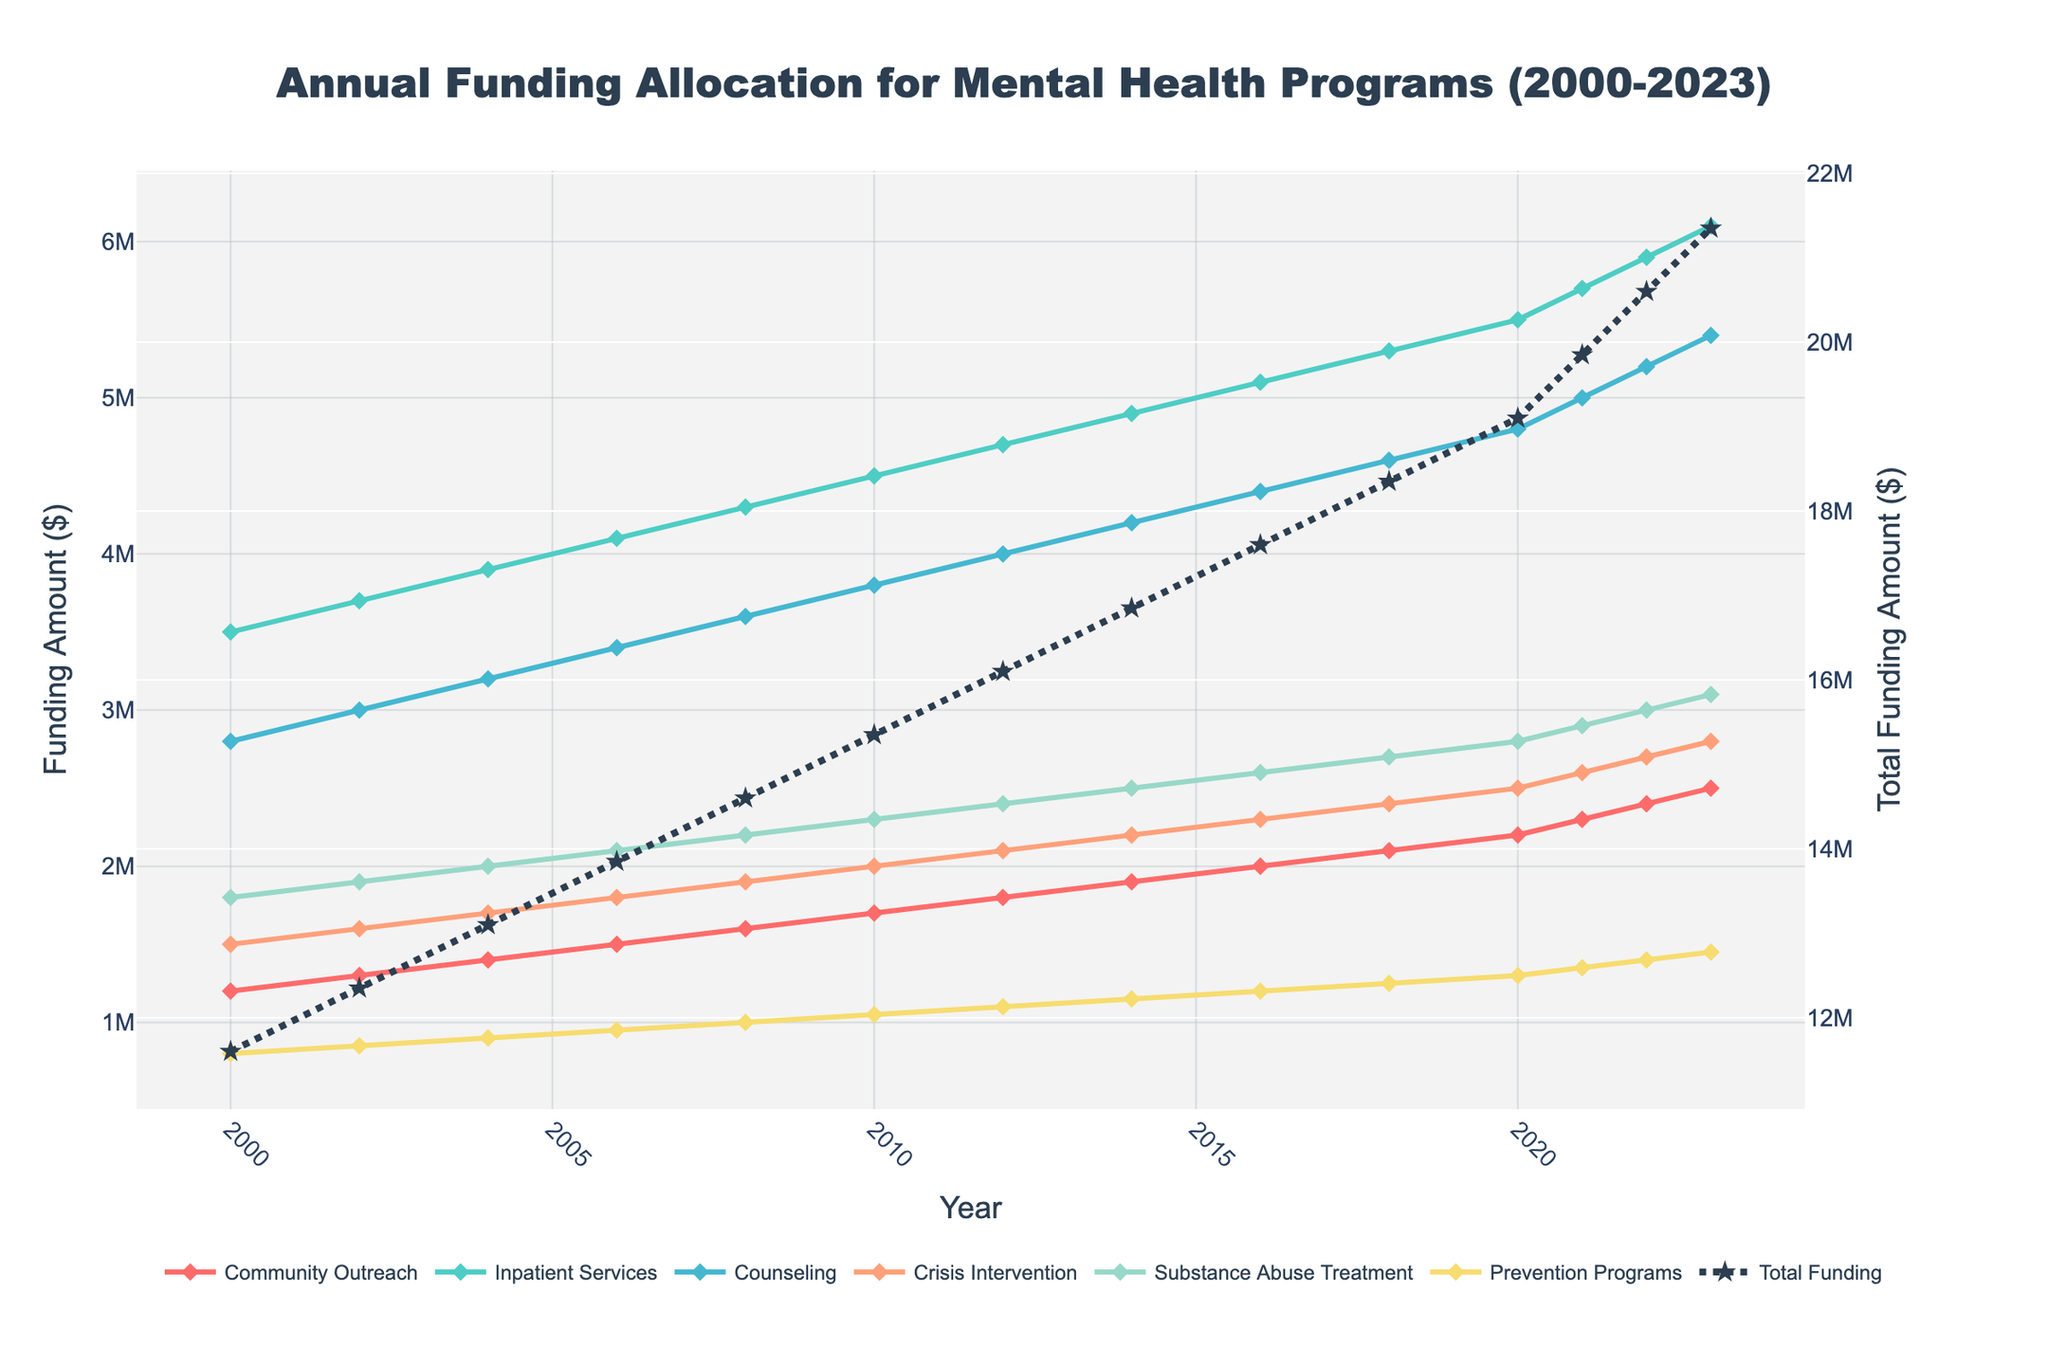Which year saw the highest total funding for mental health programs? The total funding per year is represented by a dotted line labeled "Total Funding". The year with the highest point on this line represents the highest total funding. For 2023, the total funding is at its peak as indicated by the highest point.
Answer: 2023 Which program had the largest increase in funding from 2000 to 2023? To determine which program had the largest increase, compare the funding amounts in 2000 and 2023 for each program. The difference is the largest for Inpatient Services, with funding increasing from 3,500,000 in 2000 to 6,100,000 in 2023.
Answer: Inpatient Services Compare the funding for Community Outreach in 2004 and 2018. Which year had more funding? Look at the line representing Community Outreach in 2004 and 2018. In 2004, funding was 1,400,000, while in 2018, it was 2,100,000. Thus, 2018 had more funding.
Answer: 2018 What is the average annual funding for Crisis Intervention between 2000 and 2023? Add the Crisis Intervention funding values for all the years and then divide by the number of years (14 years). The total funding sums to 240,000,000, so the average is 240,000,000 / 14.
Answer: 2400000 How does the funding trend for Substance Abuse Treatment compare to that of Prevention Programs from 2000 to 2023? Both trends can be observed by comparing the respective lines representing Substance Abuse Treatment and Prevention Programs. Substance Abuse Treatment shows a consistent upward trend from 1,800,000 in 2000 to 3,100,000 in 2023, similarly, Prevention Programs also show an upward trend from 800,000 in 2000 to 1,450,000 in 2023. Both programs exhibit continuous growth.
Answer: Both programs exhibit continuous growth In which year did Counseling funding first exceed 3,500,000? Follow the line representing Counseling and identify the first year where the value crosses the 3,500,000 mark. It first exceeds 3,500,000 in 2008.
Answer: 2008 What is the total amount of funding allocated to all programs in 2016? Add the funding amounts for all programs in 2016 as shown by their line heights. Community Outreach: 2,000,000; Inpatient Services: 5,100,000; Counseling: 4,400,000; Crisis Intervention: 2,300,000; Substance Abuse Treatment: 2,600,000; Prevention Programs: 1,200,000. The total is 17,600,000.
Answer: 17600000 Which program had the slowest growth rate in funding between 2000 and 2023? Calculate the growth rate by subtracting the 2000 value from the 2023 value for each program, and compare the results. Prevention Programs increased from 800,000 in 2000 to 1,450,000 in 2023, indicating the slowest growth among all programs.
Answer: Prevention Programs 